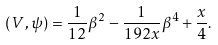Convert formula to latex. <formula><loc_0><loc_0><loc_500><loc_500>\left ( V , \psi \right ) = \frac { 1 } { 1 2 } \beta ^ { 2 } - \frac { 1 } { 1 9 2 x } \beta ^ { 4 } + \frac { x } { 4 } .</formula> 